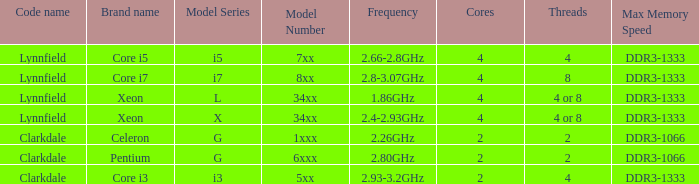What is the maximum memory speed for frequencies between 2.93-3.2ghz? DDR3-1333. 